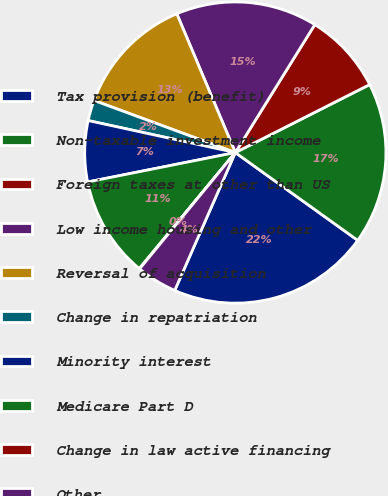Convert chart. <chart><loc_0><loc_0><loc_500><loc_500><pie_chart><fcel>Tax provision (benefit)<fcel>Non-taxable investment income<fcel>Foreign taxes at other than US<fcel>Low income housing and other<fcel>Reversal of acquisition<fcel>Change in repatriation<fcel>Minority interest<fcel>Medicare Part D<fcel>Change in law active financing<fcel>Other<nl><fcel>21.69%<fcel>17.36%<fcel>8.7%<fcel>15.2%<fcel>13.03%<fcel>2.21%<fcel>6.54%<fcel>10.87%<fcel>0.04%<fcel>4.37%<nl></chart> 